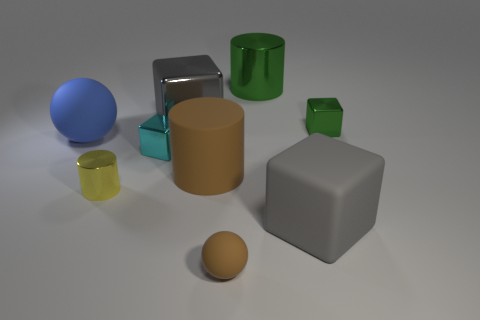Subtract all blue cylinders. Subtract all cyan spheres. How many cylinders are left? 3 Subtract all balls. How many objects are left? 7 Add 5 large metallic things. How many large metallic things exist? 7 Subtract 0 purple spheres. How many objects are left? 9 Subtract all cyan things. Subtract all large brown matte cylinders. How many objects are left? 7 Add 2 cyan blocks. How many cyan blocks are left? 3 